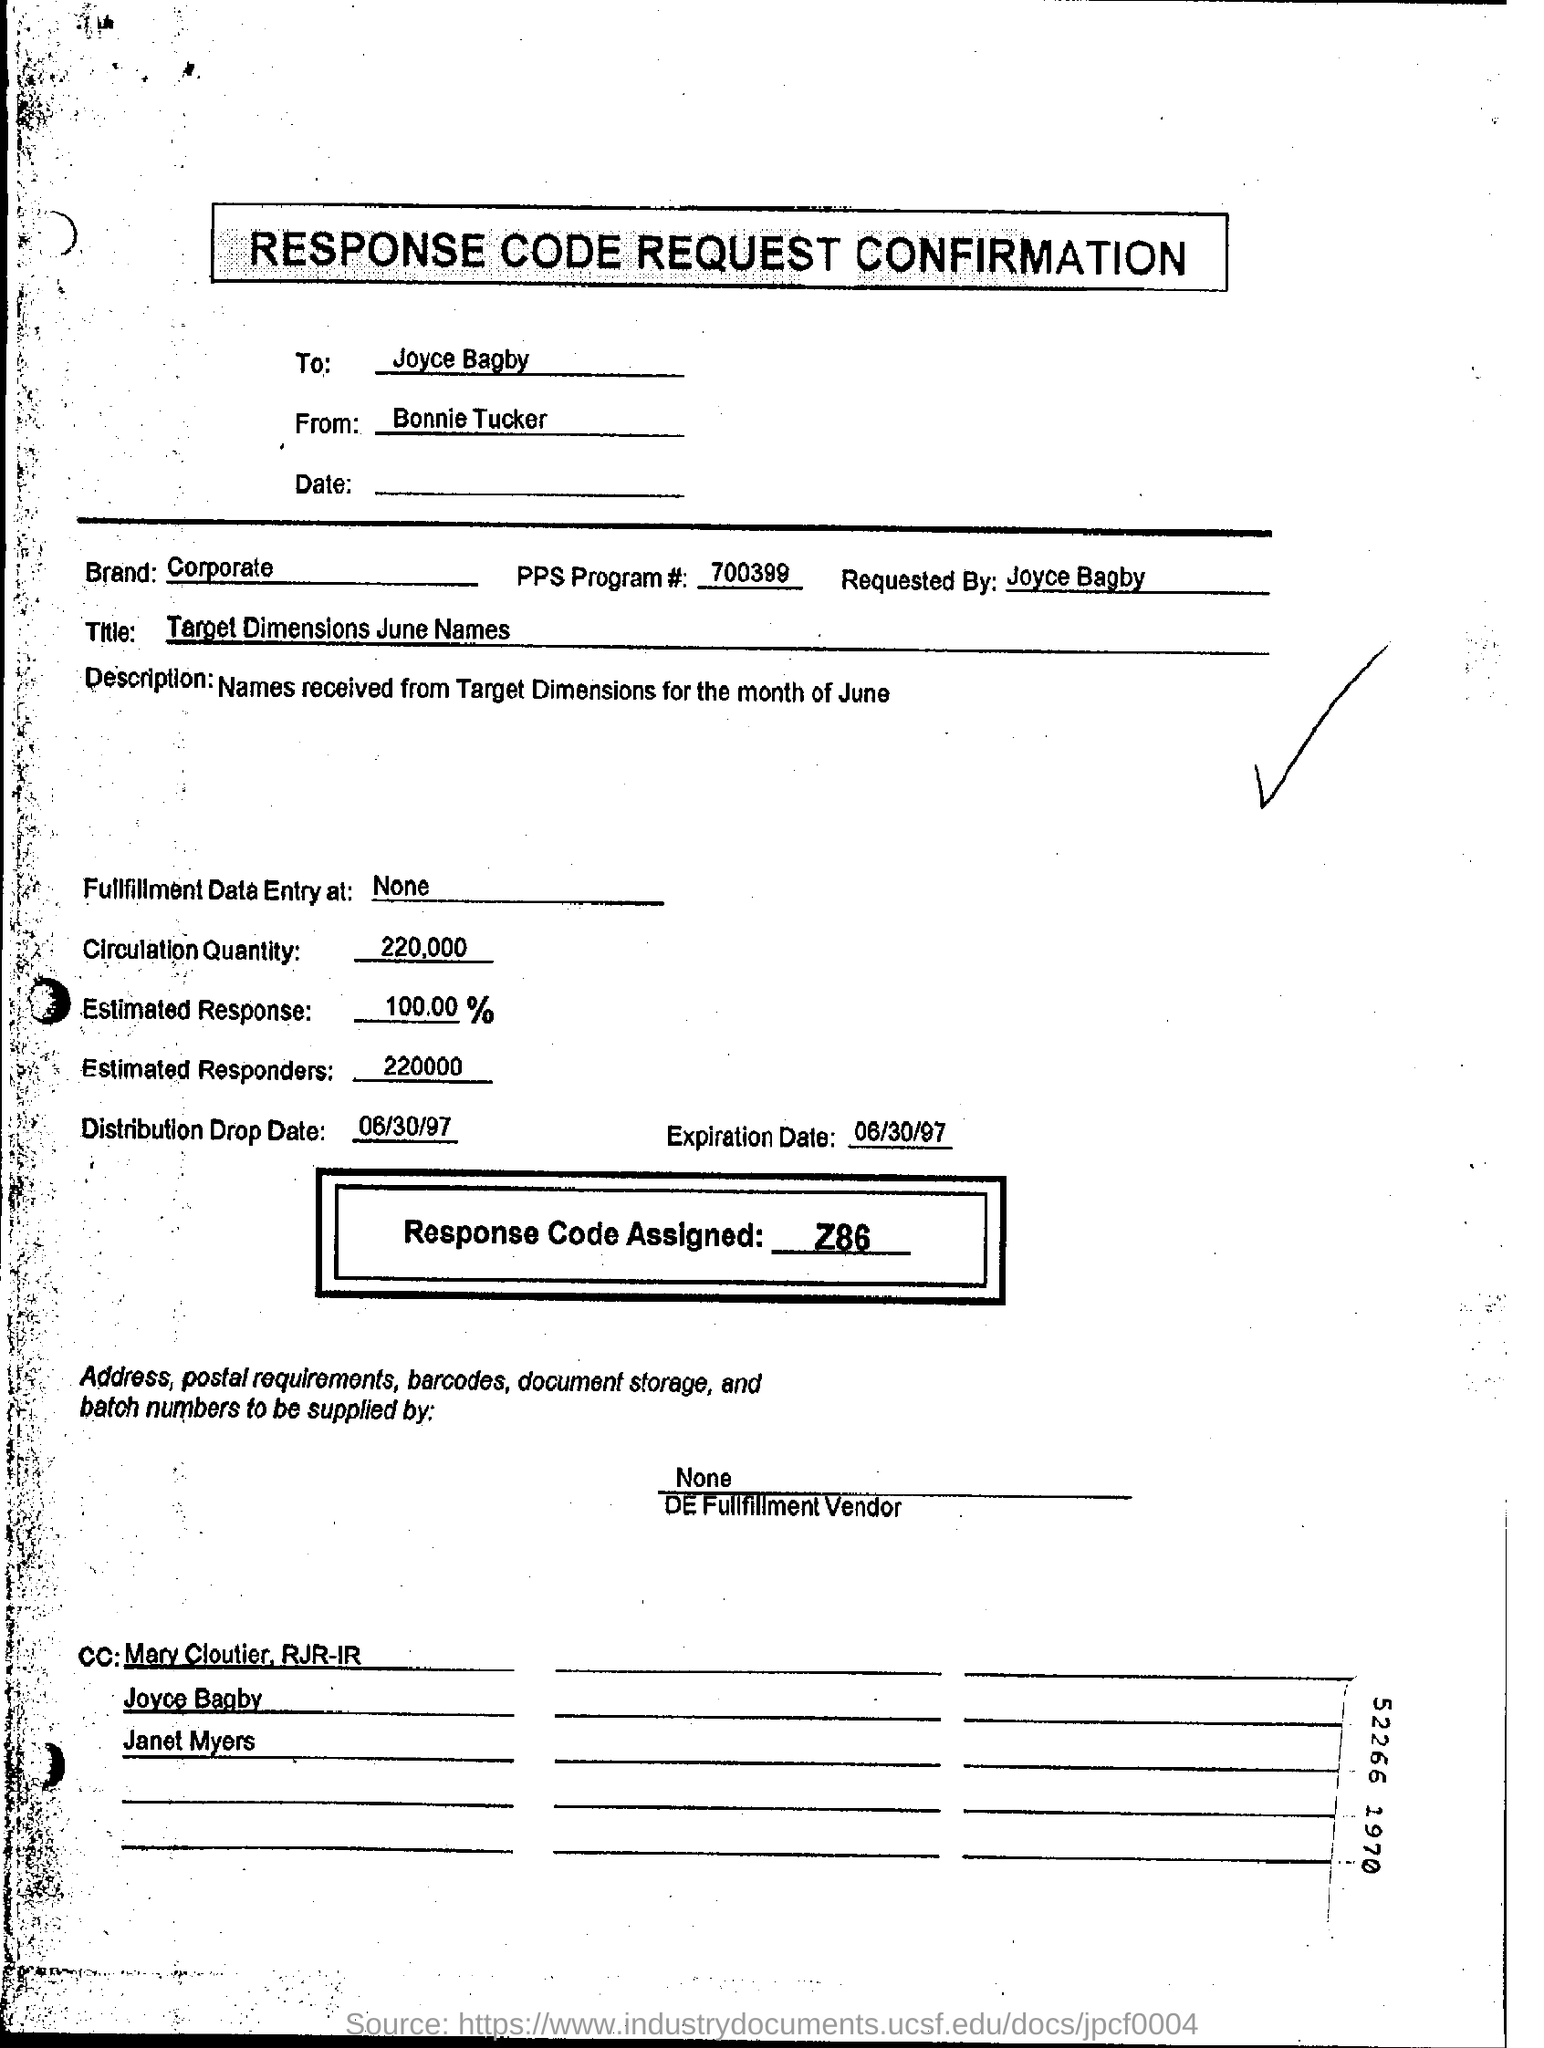Who is requesting the response code confirmation?
Offer a very short reply. Joyce Bagby. What is the number of the PPS program?
Keep it short and to the point. 700399. How much is the circulation quantity?
Your answer should be very brief. 220,000. What is the assigned response code?
Give a very brief answer. Z86. 